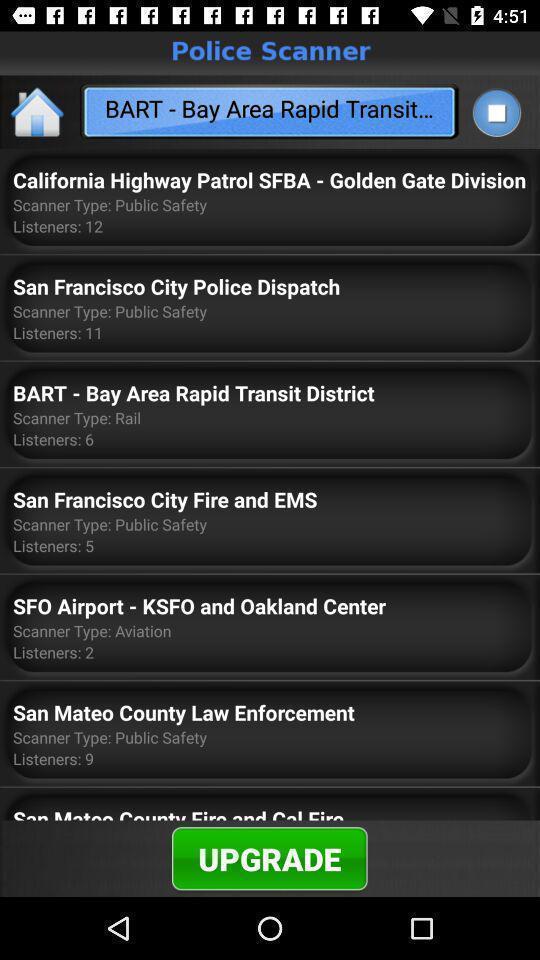Give me a narrative description of this picture. Page showing interface for a police radio scanner app. 